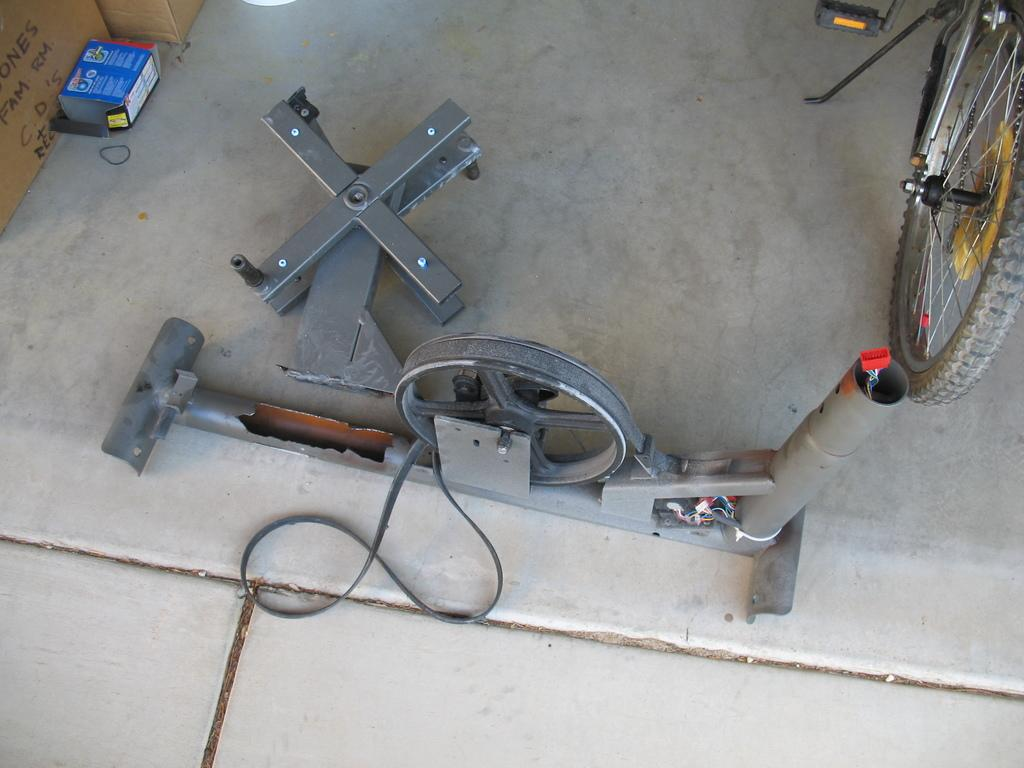What is the main object on the ground in the image? There is a machine on the ground in the image. Can you describe any other objects visible in the image? There is a part of a bicycle visible in the top right corner of the image. What type of ink is being used to draw on the machine in the image? There is no ink or drawing present in the image; it only shows a machine on the ground and a part of a bicycle. 